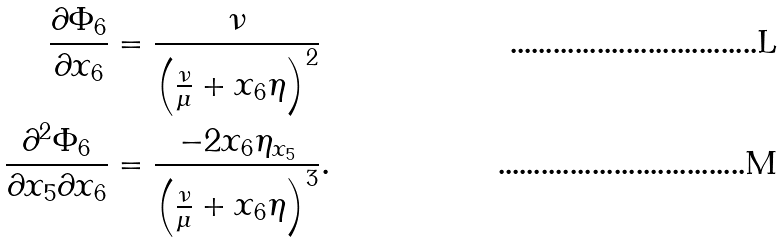<formula> <loc_0><loc_0><loc_500><loc_500>\frac { \partial \Phi _ { 6 } } { \partial x _ { 6 } } & = \frac { \nu } { \left ( \frac { \nu } { \mu } + x _ { 6 } \eta \right ) ^ { 2 } } \\ \frac { \partial ^ { 2 } \Phi _ { 6 } } { \partial x _ { 5 } \partial x _ { 6 } } & = \frac { - 2 x _ { 6 } \eta _ { x _ { 5 } } } { \left ( \frac { \nu } { \mu } + x _ { 6 } \eta \right ) ^ { 3 } } .</formula> 